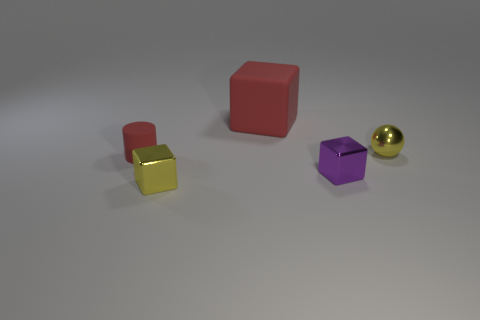Subtract all tiny blocks. How many blocks are left? 1 Add 4 large red rubber blocks. How many objects exist? 9 Subtract all yellow cubes. How many cubes are left? 2 Subtract all blocks. How many objects are left? 2 Subtract 2 blocks. How many blocks are left? 1 Subtract 0 purple balls. How many objects are left? 5 Subtract all purple cylinders. Subtract all red cubes. How many cylinders are left? 1 Subtract all cyan cylinders. How many red cubes are left? 1 Subtract all small yellow shiny balls. Subtract all tiny green cylinders. How many objects are left? 4 Add 5 yellow spheres. How many yellow spheres are left? 6 